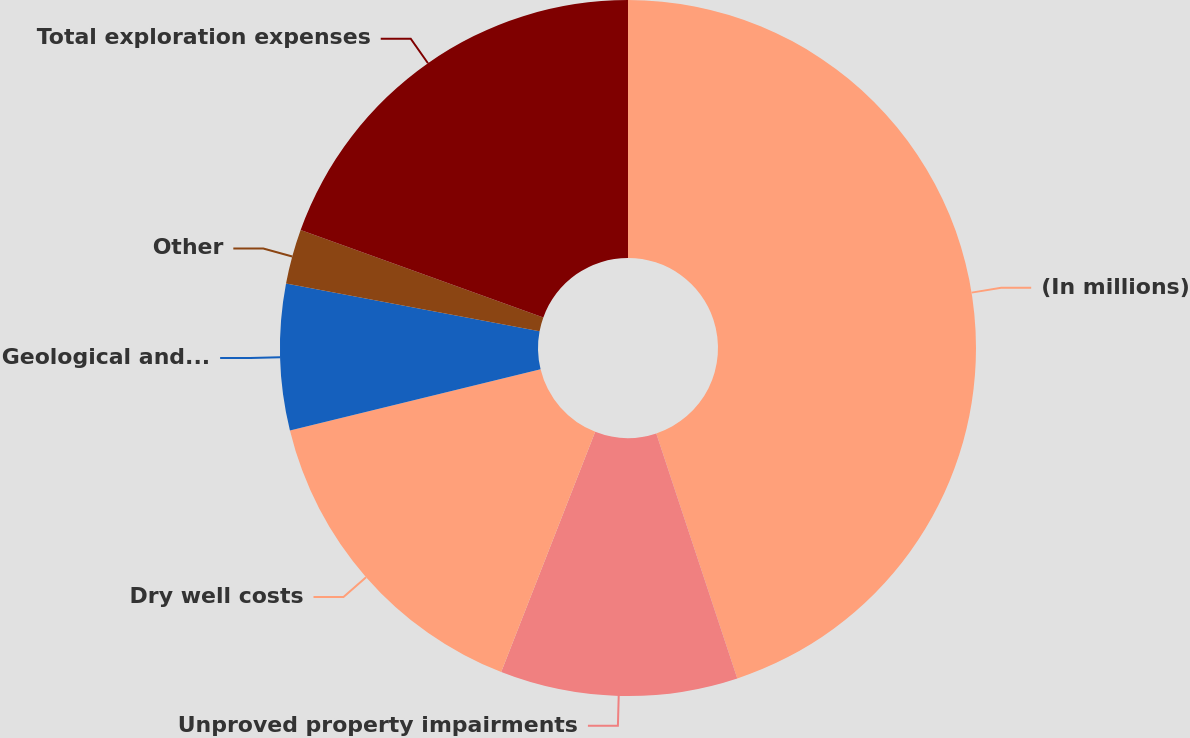<chart> <loc_0><loc_0><loc_500><loc_500><pie_chart><fcel>(In millions)<fcel>Unproved property impairments<fcel>Dry well costs<fcel>Geological and geophysical<fcel>Other<fcel>Total exploration expenses<nl><fcel>44.91%<fcel>11.02%<fcel>15.25%<fcel>6.78%<fcel>2.54%<fcel>19.49%<nl></chart> 